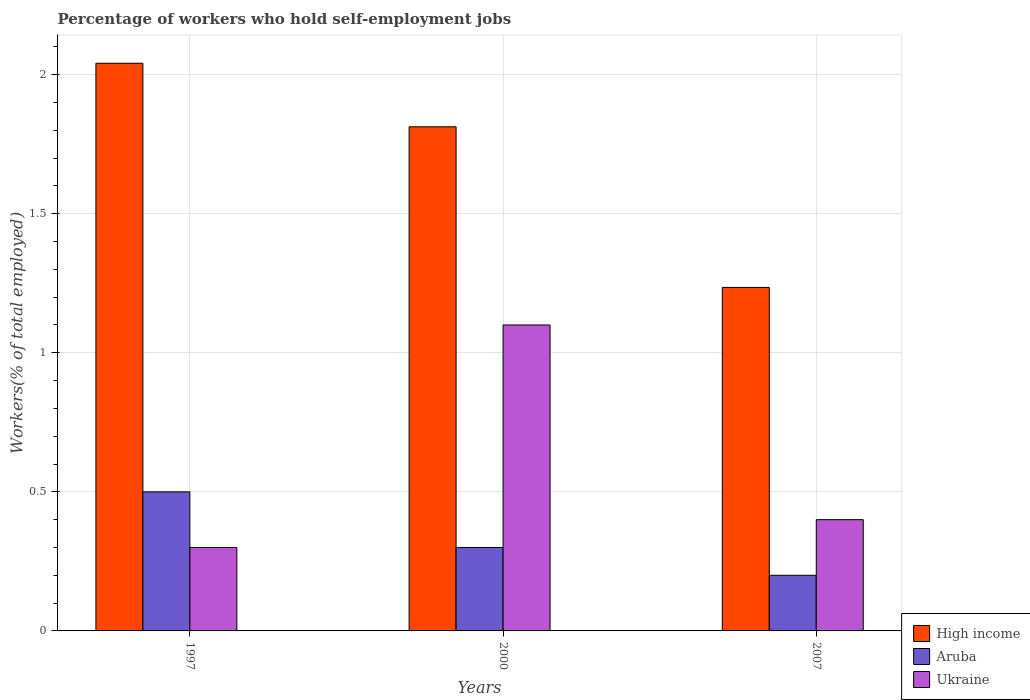How many bars are there on the 1st tick from the right?
Offer a terse response. 3. What is the label of the 3rd group of bars from the left?
Keep it short and to the point. 2007. In how many cases, is the number of bars for a given year not equal to the number of legend labels?
Ensure brevity in your answer.  0. What is the percentage of self-employed workers in Ukraine in 2007?
Provide a succinct answer. 0.4. Across all years, what is the maximum percentage of self-employed workers in Aruba?
Ensure brevity in your answer.  0.5. Across all years, what is the minimum percentage of self-employed workers in Ukraine?
Your response must be concise. 0.3. In which year was the percentage of self-employed workers in High income minimum?
Provide a short and direct response. 2007. What is the total percentage of self-employed workers in Aruba in the graph?
Offer a very short reply. 1. What is the difference between the percentage of self-employed workers in Ukraine in 1997 and that in 2007?
Provide a succinct answer. -0.1. What is the difference between the percentage of self-employed workers in Aruba in 2007 and the percentage of self-employed workers in Ukraine in 1997?
Provide a succinct answer. -0.1. What is the average percentage of self-employed workers in Ukraine per year?
Ensure brevity in your answer.  0.6. In the year 2000, what is the difference between the percentage of self-employed workers in High income and percentage of self-employed workers in Aruba?
Provide a short and direct response. 1.51. In how many years, is the percentage of self-employed workers in Ukraine greater than 1.6 %?
Offer a very short reply. 0. What is the ratio of the percentage of self-employed workers in Ukraine in 1997 to that in 2007?
Your answer should be compact. 0.75. Is the percentage of self-employed workers in High income in 1997 less than that in 2007?
Keep it short and to the point. No. What is the difference between the highest and the second highest percentage of self-employed workers in Ukraine?
Give a very brief answer. 0.7. What is the difference between the highest and the lowest percentage of self-employed workers in Ukraine?
Make the answer very short. 0.8. What does the 3rd bar from the left in 2000 represents?
Offer a very short reply. Ukraine. What does the 2nd bar from the right in 1997 represents?
Provide a succinct answer. Aruba. Is it the case that in every year, the sum of the percentage of self-employed workers in Aruba and percentage of self-employed workers in Ukraine is greater than the percentage of self-employed workers in High income?
Provide a succinct answer. No. How many bars are there?
Ensure brevity in your answer.  9. Are the values on the major ticks of Y-axis written in scientific E-notation?
Your answer should be very brief. No. Does the graph contain any zero values?
Provide a succinct answer. No. Where does the legend appear in the graph?
Provide a succinct answer. Bottom right. How many legend labels are there?
Provide a short and direct response. 3. How are the legend labels stacked?
Offer a terse response. Vertical. What is the title of the graph?
Keep it short and to the point. Percentage of workers who hold self-employment jobs. Does "Sri Lanka" appear as one of the legend labels in the graph?
Your response must be concise. No. What is the label or title of the Y-axis?
Make the answer very short. Workers(% of total employed). What is the Workers(% of total employed) in High income in 1997?
Your response must be concise. 2.04. What is the Workers(% of total employed) in Aruba in 1997?
Ensure brevity in your answer.  0.5. What is the Workers(% of total employed) of Ukraine in 1997?
Provide a short and direct response. 0.3. What is the Workers(% of total employed) in High income in 2000?
Ensure brevity in your answer.  1.81. What is the Workers(% of total employed) in Aruba in 2000?
Offer a terse response. 0.3. What is the Workers(% of total employed) of Ukraine in 2000?
Provide a succinct answer. 1.1. What is the Workers(% of total employed) of High income in 2007?
Give a very brief answer. 1.24. What is the Workers(% of total employed) of Aruba in 2007?
Provide a short and direct response. 0.2. What is the Workers(% of total employed) in Ukraine in 2007?
Offer a terse response. 0.4. Across all years, what is the maximum Workers(% of total employed) of High income?
Offer a terse response. 2.04. Across all years, what is the maximum Workers(% of total employed) in Ukraine?
Make the answer very short. 1.1. Across all years, what is the minimum Workers(% of total employed) in High income?
Make the answer very short. 1.24. Across all years, what is the minimum Workers(% of total employed) of Aruba?
Your response must be concise. 0.2. Across all years, what is the minimum Workers(% of total employed) of Ukraine?
Provide a short and direct response. 0.3. What is the total Workers(% of total employed) in High income in the graph?
Ensure brevity in your answer.  5.09. What is the total Workers(% of total employed) in Aruba in the graph?
Provide a succinct answer. 1. What is the total Workers(% of total employed) of Ukraine in the graph?
Ensure brevity in your answer.  1.8. What is the difference between the Workers(% of total employed) of High income in 1997 and that in 2000?
Offer a very short reply. 0.23. What is the difference between the Workers(% of total employed) in High income in 1997 and that in 2007?
Your response must be concise. 0.81. What is the difference between the Workers(% of total employed) in High income in 2000 and that in 2007?
Your answer should be very brief. 0.58. What is the difference between the Workers(% of total employed) of Aruba in 2000 and that in 2007?
Provide a short and direct response. 0.1. What is the difference between the Workers(% of total employed) in High income in 1997 and the Workers(% of total employed) in Aruba in 2000?
Keep it short and to the point. 1.74. What is the difference between the Workers(% of total employed) of High income in 1997 and the Workers(% of total employed) of Ukraine in 2000?
Provide a short and direct response. 0.94. What is the difference between the Workers(% of total employed) of High income in 1997 and the Workers(% of total employed) of Aruba in 2007?
Provide a succinct answer. 1.84. What is the difference between the Workers(% of total employed) of High income in 1997 and the Workers(% of total employed) of Ukraine in 2007?
Make the answer very short. 1.64. What is the difference between the Workers(% of total employed) in Aruba in 1997 and the Workers(% of total employed) in Ukraine in 2007?
Keep it short and to the point. 0.1. What is the difference between the Workers(% of total employed) of High income in 2000 and the Workers(% of total employed) of Aruba in 2007?
Your answer should be very brief. 1.61. What is the difference between the Workers(% of total employed) of High income in 2000 and the Workers(% of total employed) of Ukraine in 2007?
Ensure brevity in your answer.  1.41. What is the difference between the Workers(% of total employed) in Aruba in 2000 and the Workers(% of total employed) in Ukraine in 2007?
Offer a very short reply. -0.1. What is the average Workers(% of total employed) in High income per year?
Offer a very short reply. 1.7. What is the average Workers(% of total employed) of Aruba per year?
Make the answer very short. 0.33. What is the average Workers(% of total employed) of Ukraine per year?
Your answer should be compact. 0.6. In the year 1997, what is the difference between the Workers(% of total employed) in High income and Workers(% of total employed) in Aruba?
Your answer should be compact. 1.54. In the year 1997, what is the difference between the Workers(% of total employed) of High income and Workers(% of total employed) of Ukraine?
Offer a terse response. 1.74. In the year 2000, what is the difference between the Workers(% of total employed) in High income and Workers(% of total employed) in Aruba?
Your response must be concise. 1.51. In the year 2000, what is the difference between the Workers(% of total employed) of High income and Workers(% of total employed) of Ukraine?
Give a very brief answer. 0.71. In the year 2007, what is the difference between the Workers(% of total employed) of High income and Workers(% of total employed) of Aruba?
Your response must be concise. 1.04. In the year 2007, what is the difference between the Workers(% of total employed) in High income and Workers(% of total employed) in Ukraine?
Give a very brief answer. 0.84. What is the ratio of the Workers(% of total employed) of High income in 1997 to that in 2000?
Provide a succinct answer. 1.13. What is the ratio of the Workers(% of total employed) of Ukraine in 1997 to that in 2000?
Offer a very short reply. 0.27. What is the ratio of the Workers(% of total employed) in High income in 1997 to that in 2007?
Provide a short and direct response. 1.65. What is the ratio of the Workers(% of total employed) in Ukraine in 1997 to that in 2007?
Make the answer very short. 0.75. What is the ratio of the Workers(% of total employed) of High income in 2000 to that in 2007?
Offer a very short reply. 1.47. What is the ratio of the Workers(% of total employed) in Ukraine in 2000 to that in 2007?
Make the answer very short. 2.75. What is the difference between the highest and the second highest Workers(% of total employed) of High income?
Your answer should be compact. 0.23. What is the difference between the highest and the second highest Workers(% of total employed) in Ukraine?
Offer a terse response. 0.7. What is the difference between the highest and the lowest Workers(% of total employed) of High income?
Give a very brief answer. 0.81. What is the difference between the highest and the lowest Workers(% of total employed) in Aruba?
Keep it short and to the point. 0.3. 